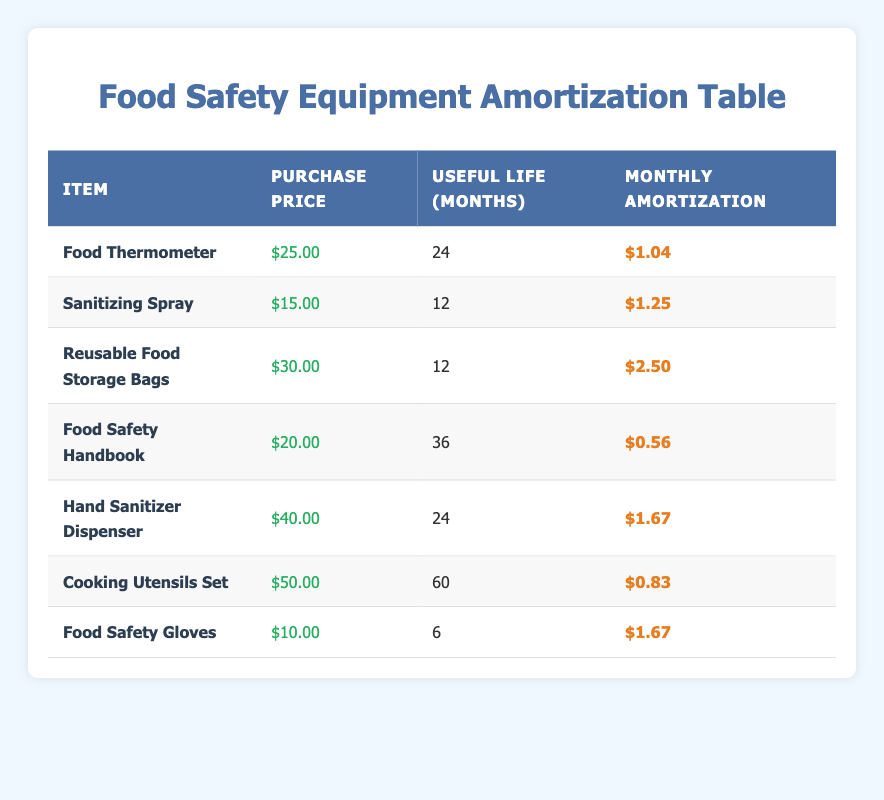What is the monthly amortization for the Food Thermometer? According to the table, the Food Thermometer has a monthly amortization value of $1.04.
Answer: $1.04 How long is the useful life of the Reusable Food Storage Bags? The table indicates that the useful life of the Reusable Food Storage Bags is 12 months.
Answer: 12 months What is the average purchase price of all the items listed? To find the average purchase price, we sum the purchase prices (25 + 15 + 30 + 20 + 40 + 50 + 10 = 190) and then divide by the number of items (7). So, the average is 190/7 = 27.14.
Answer: 27.14 Is the monthly amortization for the Food Safety Handbook less than $1? The monthly amortization for the Food Safety Handbook is $0.56, which is indeed less than $1.
Answer: Yes Which item has the longest useful life and what is that duration? The Cooking Utensils Set has the longest useful life listed in the table at 60 months. This can be confirmed by comparing the useful life values of all items.
Answer: 60 months Which two items have the same monthly amortization of $1.67? The Hand Sanitizer Dispenser and Food Safety Gloves both have the same monthly amortization of $1.67. This can be confirmed by checking the amortization column for these items.
Answer: Hand Sanitizer Dispenser and Food Safety Gloves If I wanted to know the total monthly amortization for all items, how would I calculate it? To find the total monthly amortization, add up the monthly amortization values for all items ($1.04 + $1.25 + $2.50 + $0.56 + $1.67 + $0.83 + $1.67 = 9.52). Thus, the total monthly amortization for all items is $9.52.
Answer: $9.52 What is the purchase price of the Sanitizing Spray compared to the Food Safety Gloves? The purchase price of the Sanitizing Spray is $15.00, while the Food Safety Gloves cost $10.00. Thus, the Sanitizing Spray is $5.00 more expensive than the Food Safety Gloves.
Answer: $5.00 Are all items listed in the table above $5 in purchase price? No, the Food Safety Gloves cost $10, which is above $5, but all other items also exceed $5 in price. Therefore, the statement is true regarding all but the Food Safety Gloves.
Answer: No 